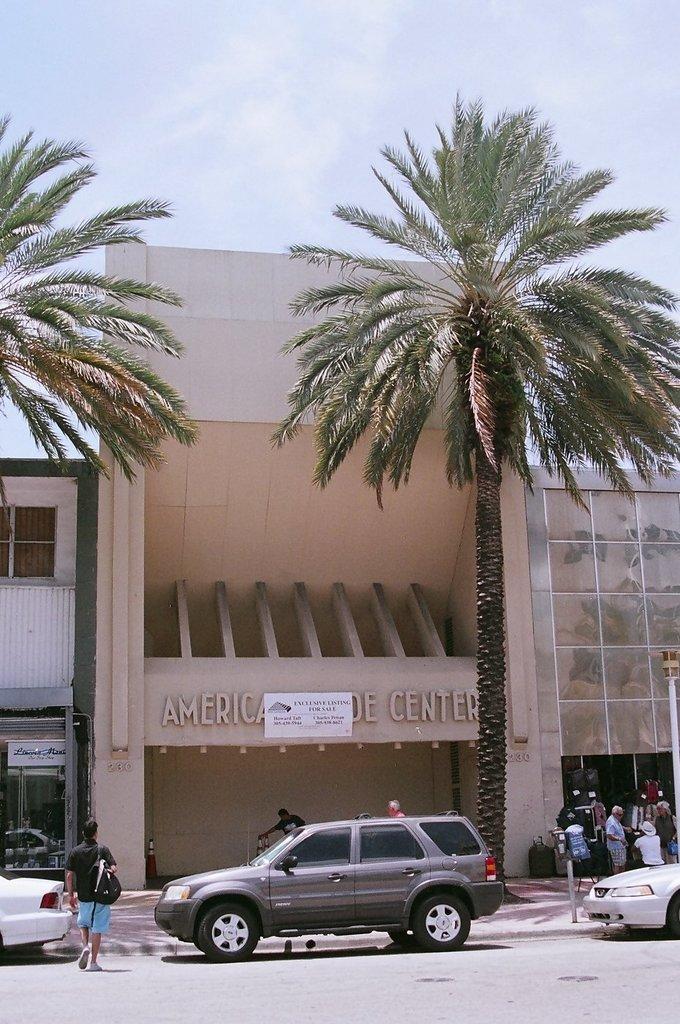In one or two sentences, can you explain what this image depicts? In this image there is the sky towards the top of the image, there is a building, there is text on the building, there is a paper on the building, there is text on the paper, there are trees, there is road towards the bottom of the image, there are vehicles on the road, there is a man walking on the road, he is wearing a bag, there is a man holding an object, there are a group of persons towards the right of the image, there is a board towards the left of the image, there is text on the board. 